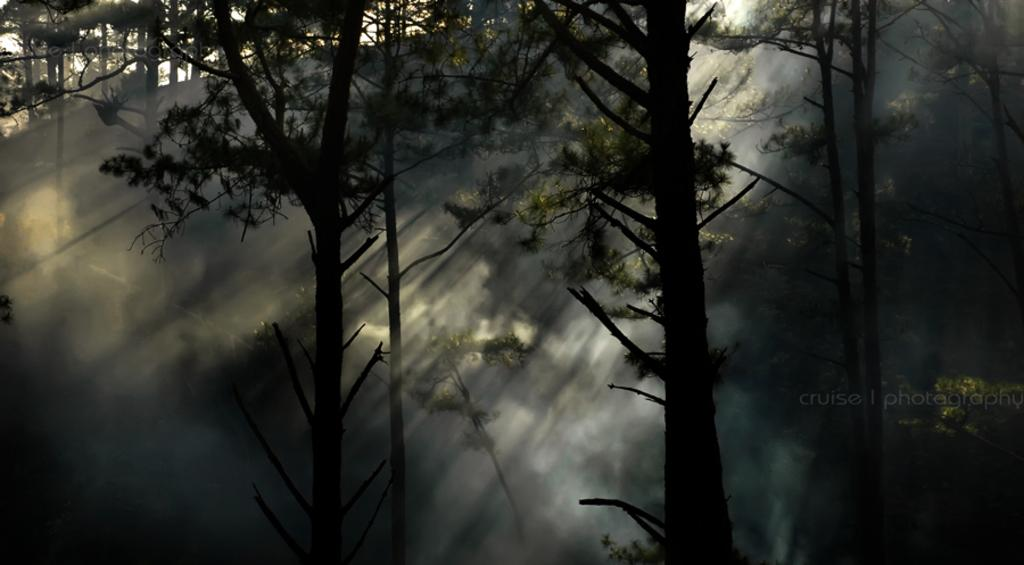What type of natural elements can be seen in the image? There are trees in the image. What can be observed about the lighting in the image? Sun rays are visible in the image. Can you see a boat floating among the trees in the image? There is no boat present in the image; it only features trees and sun rays. What type of fruit is hanging from the branches of the trees in the image? There is no fruit visible on the trees in the image. 